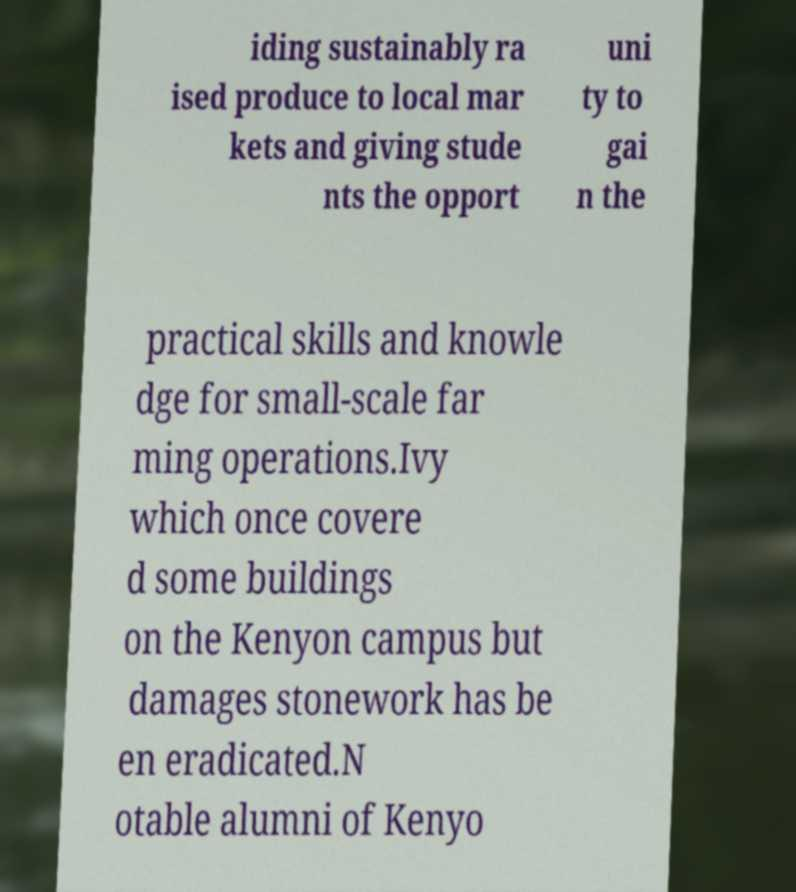Could you extract and type out the text from this image? iding sustainably ra ised produce to local mar kets and giving stude nts the opport uni ty to gai n the practical skills and knowle dge for small-scale far ming operations.Ivy which once covere d some buildings on the Kenyon campus but damages stonework has be en eradicated.N otable alumni of Kenyo 